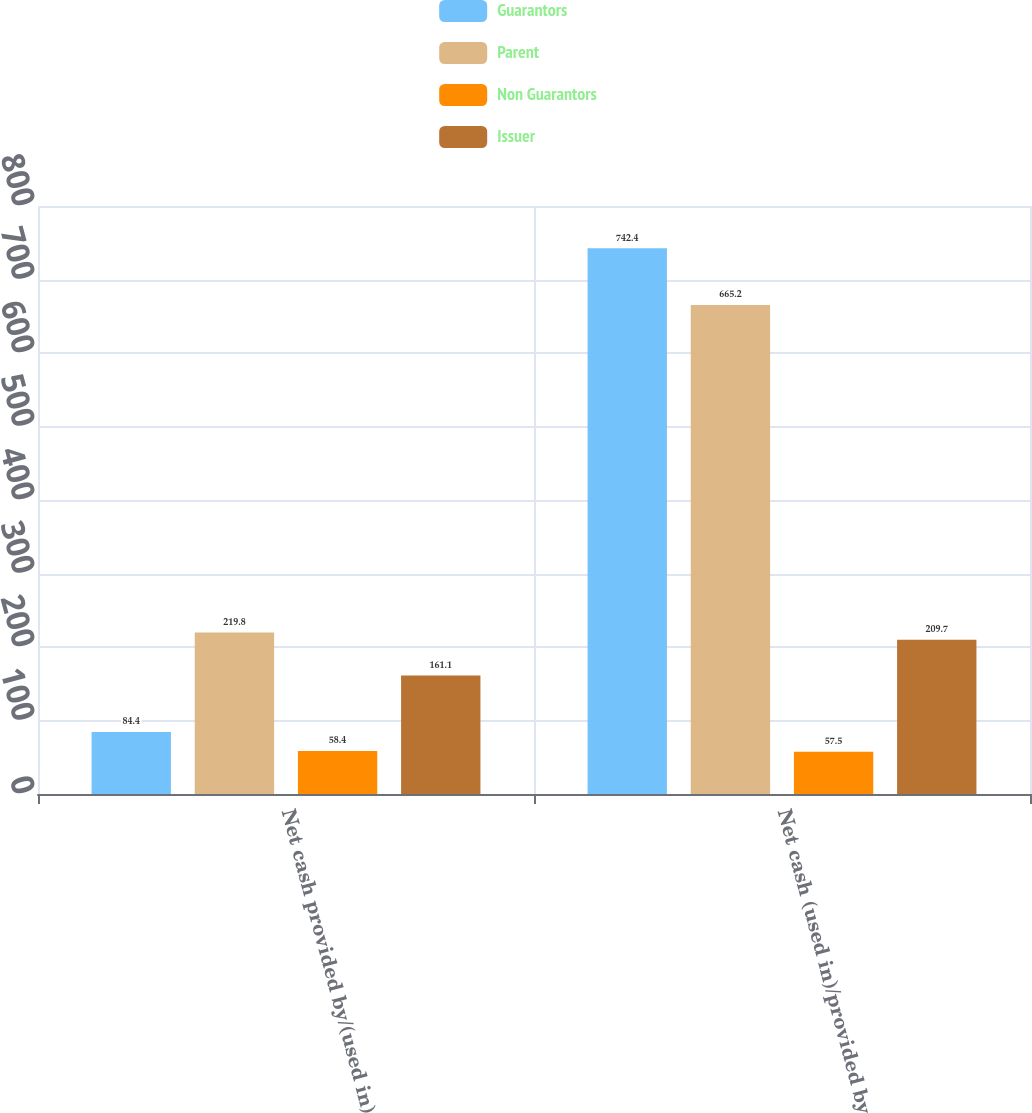<chart> <loc_0><loc_0><loc_500><loc_500><stacked_bar_chart><ecel><fcel>Net cash provided by/(used in)<fcel>Net cash (used in)/provided by<nl><fcel>Guarantors<fcel>84.4<fcel>742.4<nl><fcel>Parent<fcel>219.8<fcel>665.2<nl><fcel>Non Guarantors<fcel>58.4<fcel>57.5<nl><fcel>Issuer<fcel>161.1<fcel>209.7<nl></chart> 